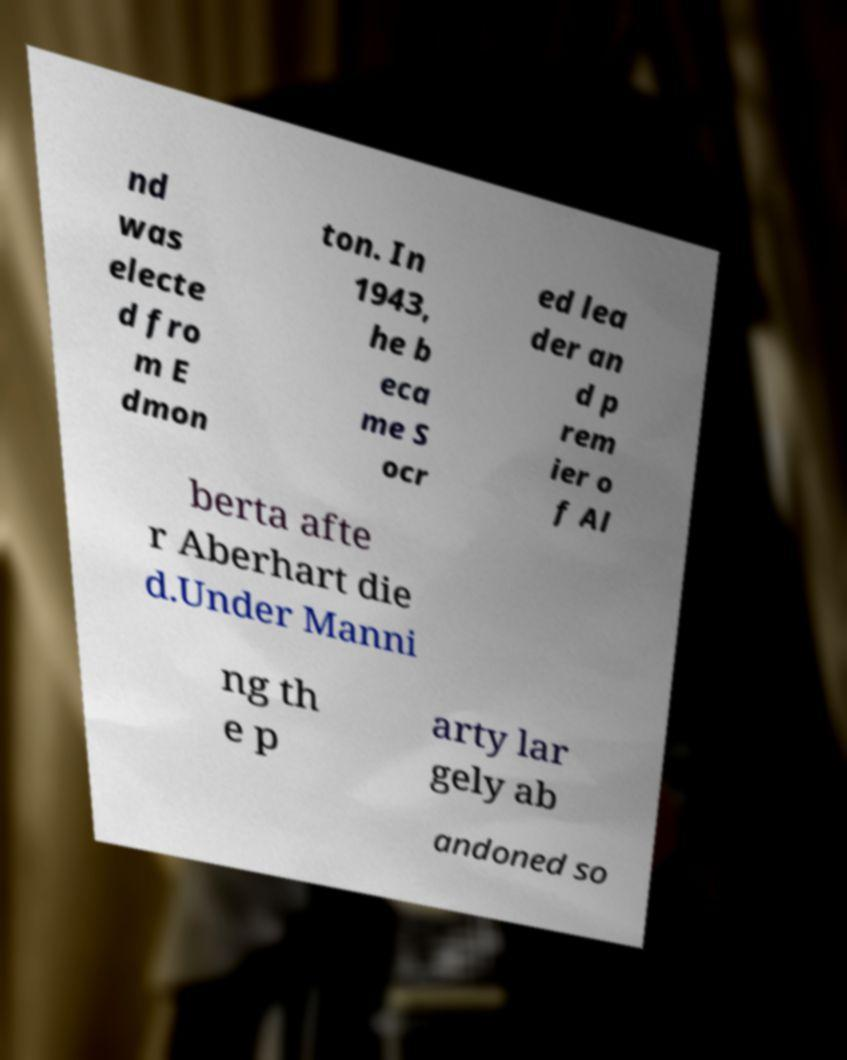I need the written content from this picture converted into text. Can you do that? nd was electe d fro m E dmon ton. In 1943, he b eca me S ocr ed lea der an d p rem ier o f Al berta afte r Aberhart die d.Under Manni ng th e p arty lar gely ab andoned so 